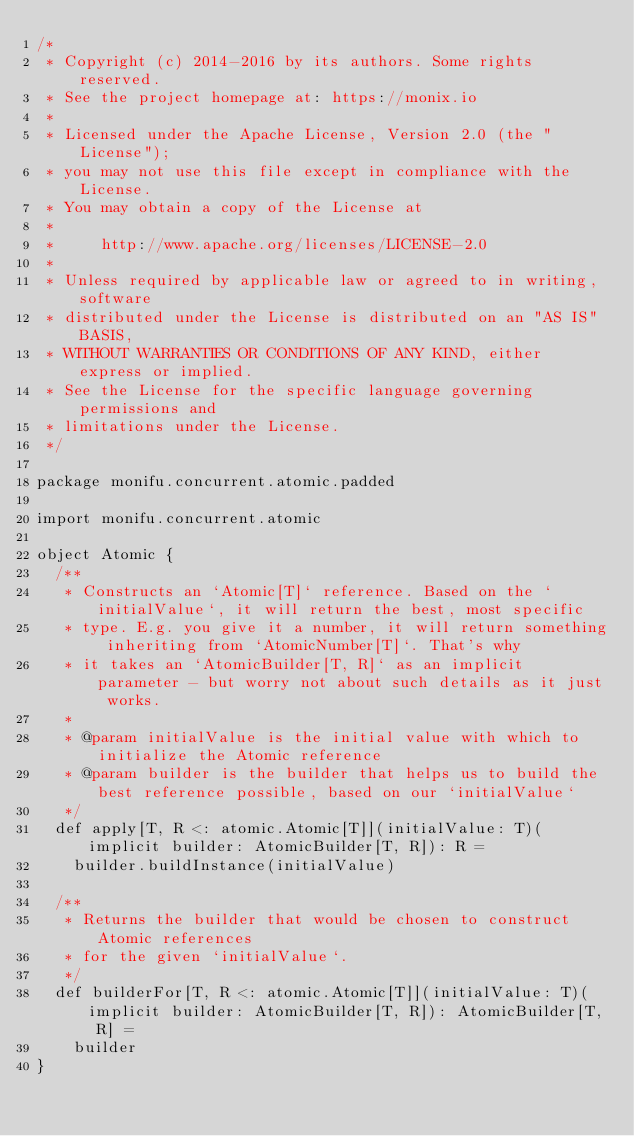Convert code to text. <code><loc_0><loc_0><loc_500><loc_500><_Scala_>/*
 * Copyright (c) 2014-2016 by its authors. Some rights reserved.
 * See the project homepage at: https://monix.io
 *
 * Licensed under the Apache License, Version 2.0 (the "License");
 * you may not use this file except in compliance with the License.
 * You may obtain a copy of the License at
 *
 *     http://www.apache.org/licenses/LICENSE-2.0
 *
 * Unless required by applicable law or agreed to in writing, software
 * distributed under the License is distributed on an "AS IS" BASIS,
 * WITHOUT WARRANTIES OR CONDITIONS OF ANY KIND, either express or implied.
 * See the License for the specific language governing permissions and
 * limitations under the License.
 */

package monifu.concurrent.atomic.padded

import monifu.concurrent.atomic

object Atomic {
  /**
   * Constructs an `Atomic[T]` reference. Based on the `initialValue`, it will return the best, most specific
   * type. E.g. you give it a number, it will return something inheriting from `AtomicNumber[T]`. That's why
   * it takes an `AtomicBuilder[T, R]` as an implicit parameter - but worry not about such details as it just works.
   *
   * @param initialValue is the initial value with which to initialize the Atomic reference
   * @param builder is the builder that helps us to build the best reference possible, based on our `initialValue`
   */
  def apply[T, R <: atomic.Atomic[T]](initialValue: T)(implicit builder: AtomicBuilder[T, R]): R =
    builder.buildInstance(initialValue)

  /**
   * Returns the builder that would be chosen to construct Atomic references
   * for the given `initialValue`.
   */
  def builderFor[T, R <: atomic.Atomic[T]](initialValue: T)(implicit builder: AtomicBuilder[T, R]): AtomicBuilder[T, R] =
    builder
}
</code> 